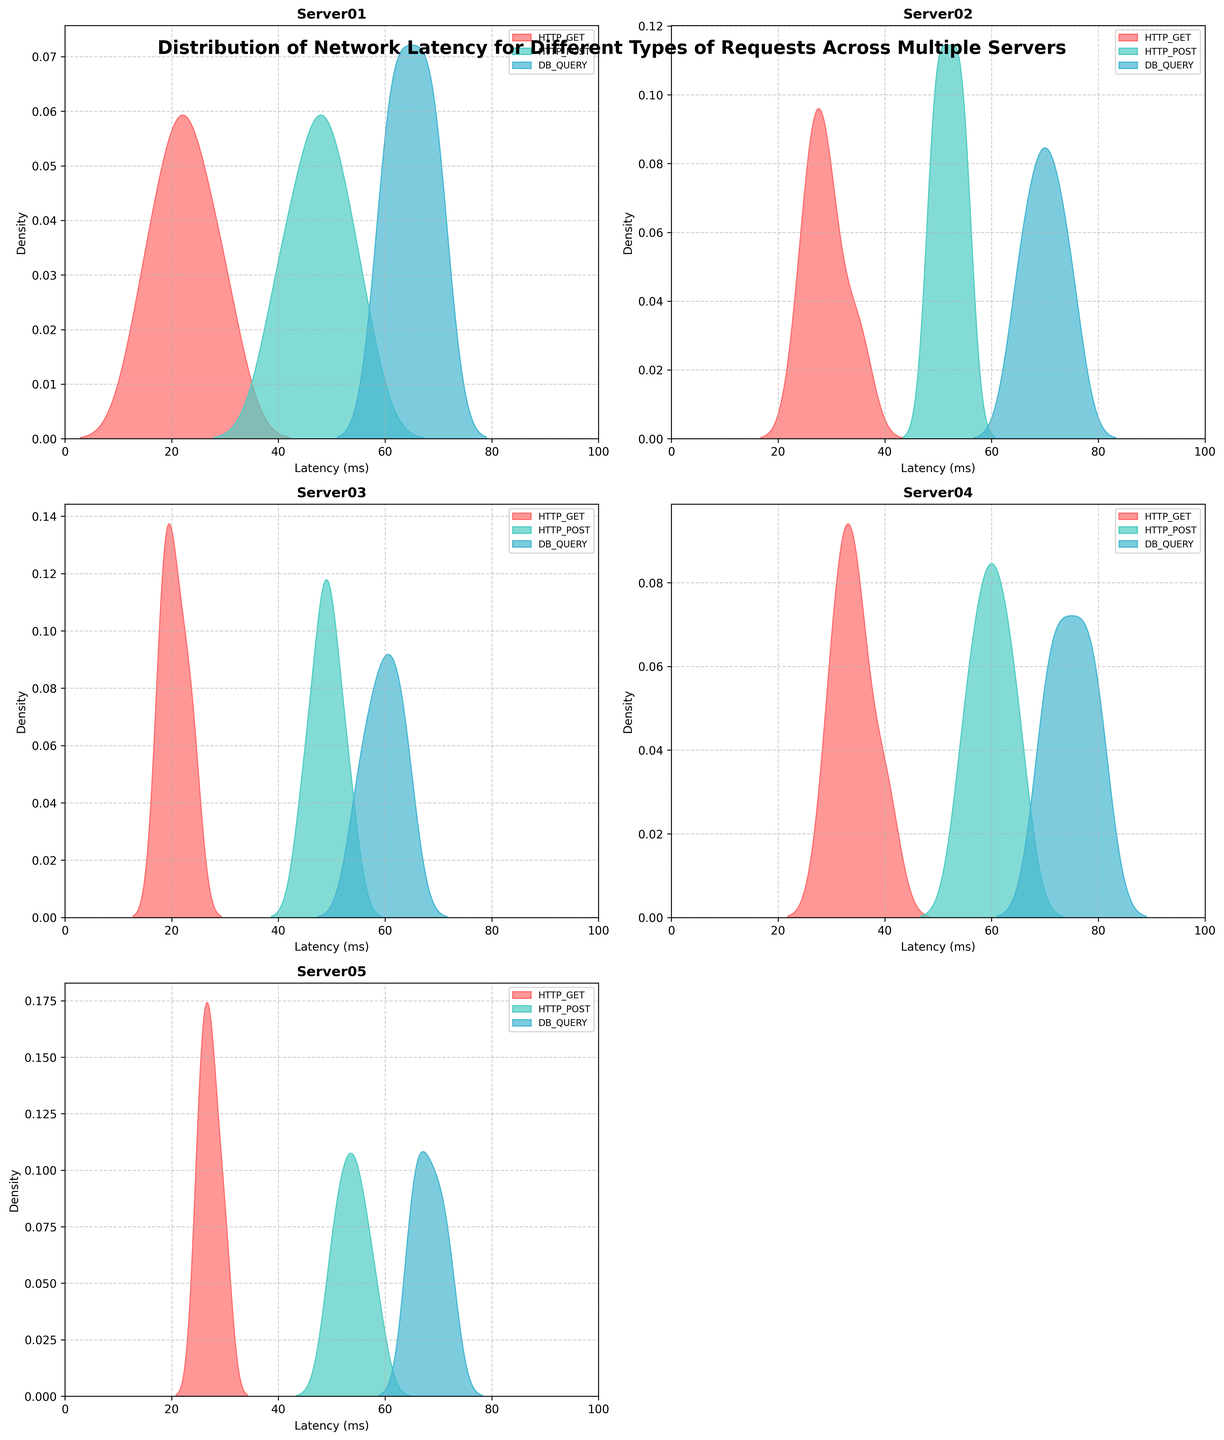How many servers are compared in the figure? The figure compares the distributions of network latency across individual plots for each server. By counting the individual titles, we identify 5 servers: Server01, Server02, Server03, Server04, and Server05.
Answer: 5 Which request type has the highest latency on Server04? Looking at the density plots for Server04, the DB_QUERY request type has the highest density peak at around 75-80 ms, indicating the highest latency.
Answer: DB_QUERY How does the latency distribution of HTTP_GET requests for Server01 compare to Server05? On Server01, the HTTP_GET latency distribution is concentrated around 15-30 ms, while for Server05, it is spread out from 25-30 ms. The latency is generally lower for Server01 and more spread for Server05.
Answer: Lower on Server01 Is there any request type that exhibits consistent latency across all servers? Observing the density plots for all servers, HTTP_POST requests appear to have a consistently high latency range, centered around 45-60 ms across all servers.
Answer: HTTP_POST What is the range of latencies for DB_QUERY requests on Server02? The density plot of DB_QUERY requests for Server02 shows the main peaks within the range of 65-75 ms.
Answer: 65-75 ms Which server has the most varied latency for HTTP_GET requests? Server04 shows the most varied latency for HTTP_GET requests, with a broad distribution ranging from 30 to 40 ms.
Answer: Server04 Compare the latency distributions of HTTP_POST requests between Server03 and Server04. On Server03, the HTTP_POST latency distribution is concentrated around 45-50 ms, whereas Server04 shows a wider distribution from 55-65 ms, indicating higher latency on Server04.
Answer: Higher on Server04 What is the common observation about DB_QUERY latency distribution across all servers? All servers exhibit DB_QUERY latency distributions that generally show higher latency values, commonly peaking around 60-80 ms.
Answer: Higher latency values ranging 60-80 ms Which request type shows the least latency variation on Server05? The HTTP_GET requests for Server05 exhibit the least latency variation, with a tight distribution around 25-30 ms.
Answer: HTTP_GET Do HTTP_GET and HTTP_POST requests have overlapping latency ranges? If yes, in which server(s)? Yes, HTTP_GET and HTTP_POST requests have overlapping latency ranges in Server05, where HTTP_GET ranges from 25 to 30 ms and HTTP_POST ranges from 50 to 55 ms, with slight overlap in the lower part of the HTTP_POST range.
Answer: Server05 